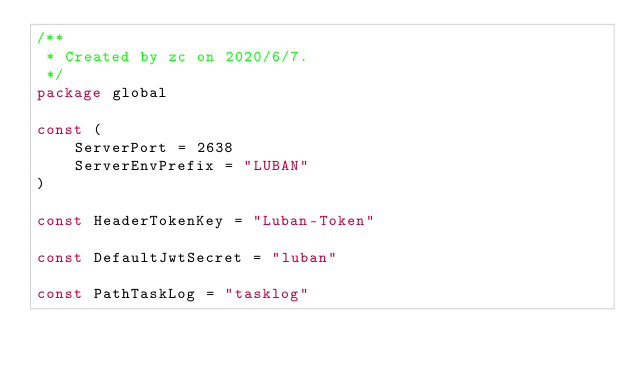<code> <loc_0><loc_0><loc_500><loc_500><_Go_>/**
 * Created by zc on 2020/6/7.
 */
package global

const (
	ServerPort = 2638
	ServerEnvPrefix = "LUBAN"
)

const HeaderTokenKey = "Luban-Token"

const DefaultJwtSecret = "luban"

const PathTaskLog = "tasklog"
</code> 